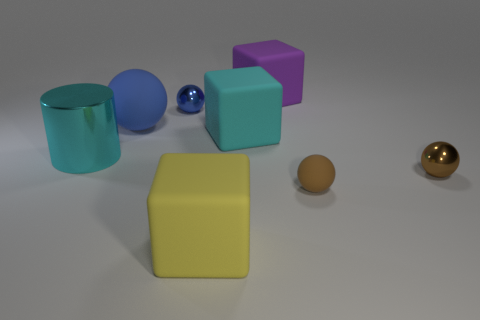The purple thing that is the same shape as the cyan rubber thing is what size?
Keep it short and to the point. Large. How many big matte things are the same color as the big shiny object?
Ensure brevity in your answer.  1. Are the cube that is in front of the big cyan metal object and the small blue thing made of the same material?
Offer a very short reply. No. How many purple cubes are the same size as the yellow block?
Your answer should be compact. 1. Is the number of large yellow matte things that are on the left side of the big yellow matte cube greater than the number of cyan things in front of the large cyan metal thing?
Ensure brevity in your answer.  No. Is there a yellow rubber object of the same shape as the big purple rubber object?
Keep it short and to the point. Yes. What is the size of the cube that is in front of the tiny shiny ball to the right of the blue metal ball?
Make the answer very short. Large. The large cyan object right of the metal ball that is to the left of the tiny brown ball that is left of the brown shiny object is what shape?
Provide a succinct answer. Cube. There is another ball that is the same material as the tiny blue sphere; what is its size?
Provide a succinct answer. Small. Is the number of rubber blocks greater than the number of brown matte cylinders?
Your answer should be compact. Yes. 